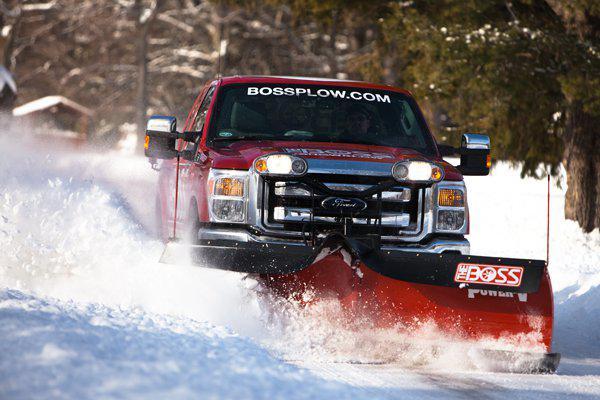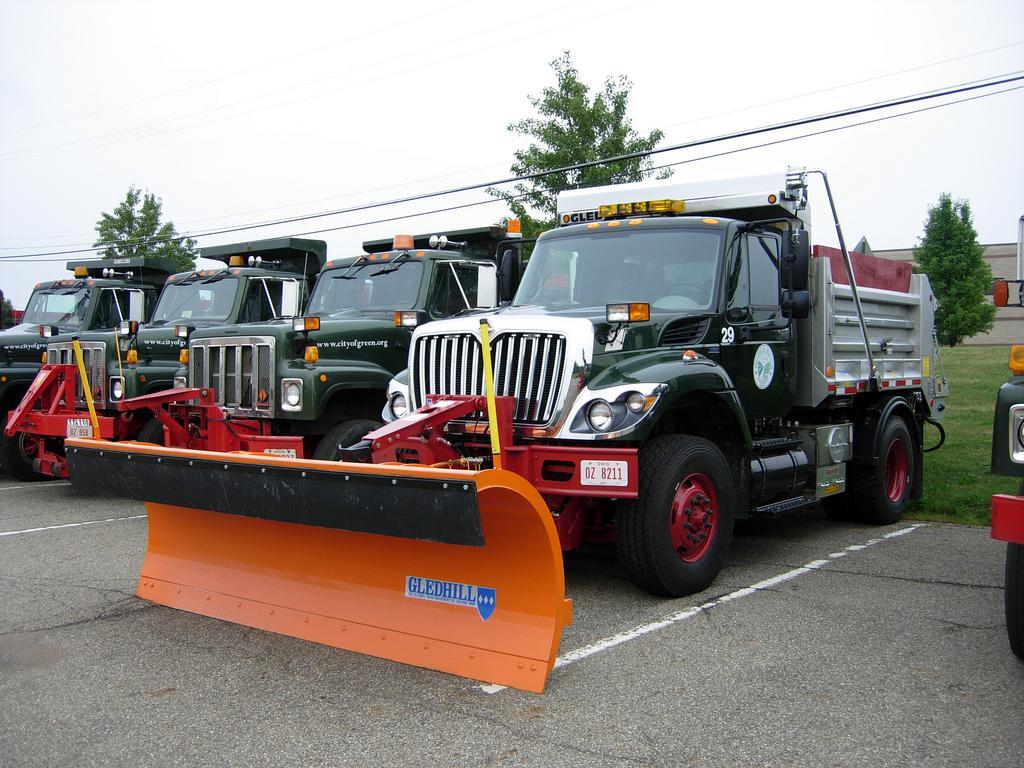The first image is the image on the left, the second image is the image on the right. For the images shown, is this caption "There are two or more trucks in the right image." true? Answer yes or no. Yes. The first image is the image on the left, the second image is the image on the right. For the images shown, is this caption "The left image shows a red truck with a red plow on its front, pushing snow and headed toward the camera." true? Answer yes or no. Yes. 